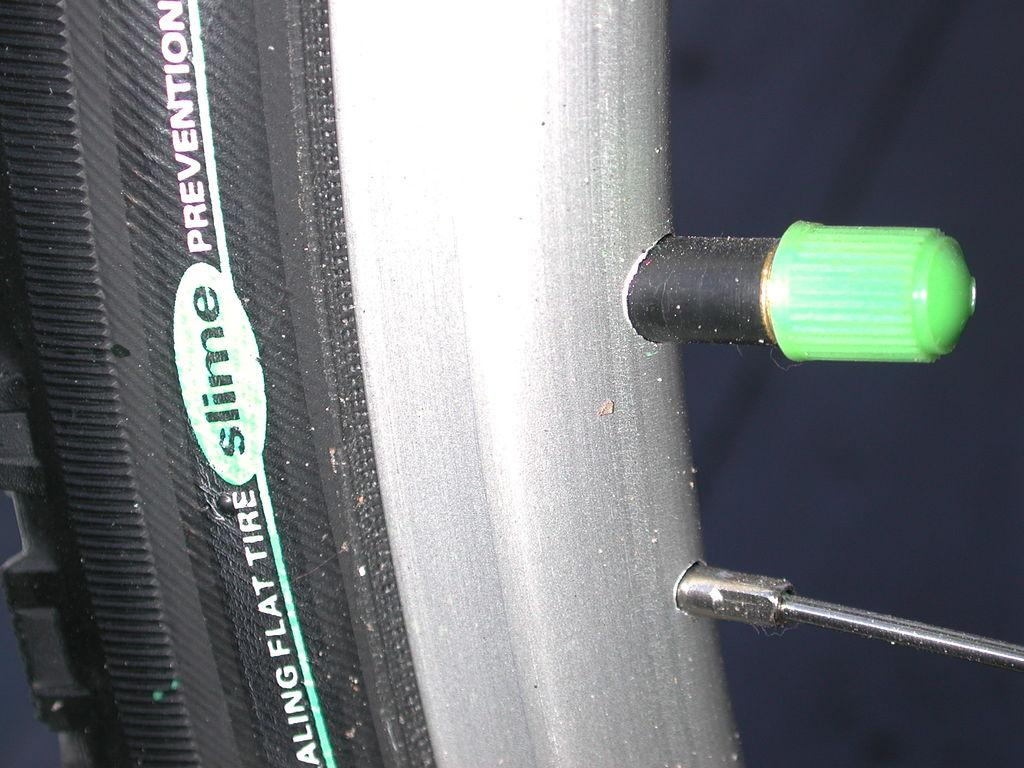Provide a one-sentence caption for the provided image. Flat tire slime prevention type of tire for a bike. 